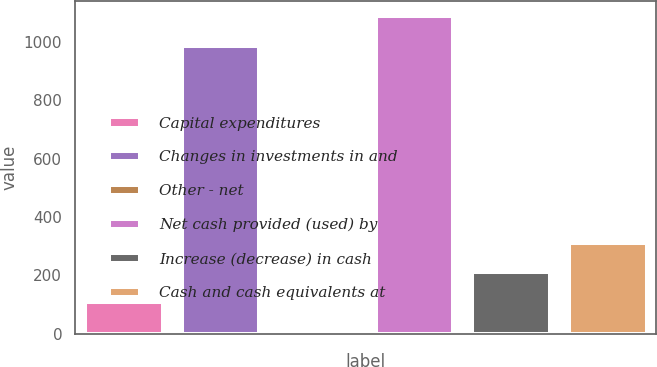Convert chart. <chart><loc_0><loc_0><loc_500><loc_500><bar_chart><fcel>Capital expenditures<fcel>Changes in investments in and<fcel>Other - net<fcel>Net cash provided (used) by<fcel>Increase (decrease) in cash<fcel>Cash and cash equivalents at<nl><fcel>109.2<fcel>985<fcel>8<fcel>1086.2<fcel>210.4<fcel>311.6<nl></chart> 